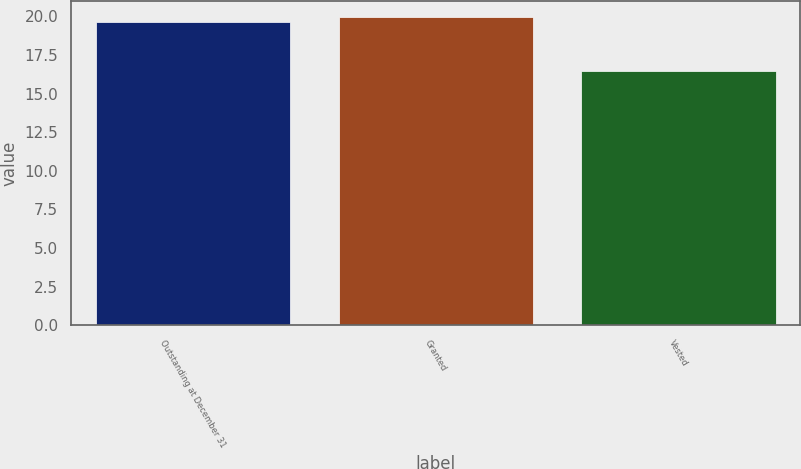Convert chart. <chart><loc_0><loc_0><loc_500><loc_500><bar_chart><fcel>Outstanding at December 31<fcel>Granted<fcel>Vested<nl><fcel>19.64<fcel>19.96<fcel>16.44<nl></chart> 